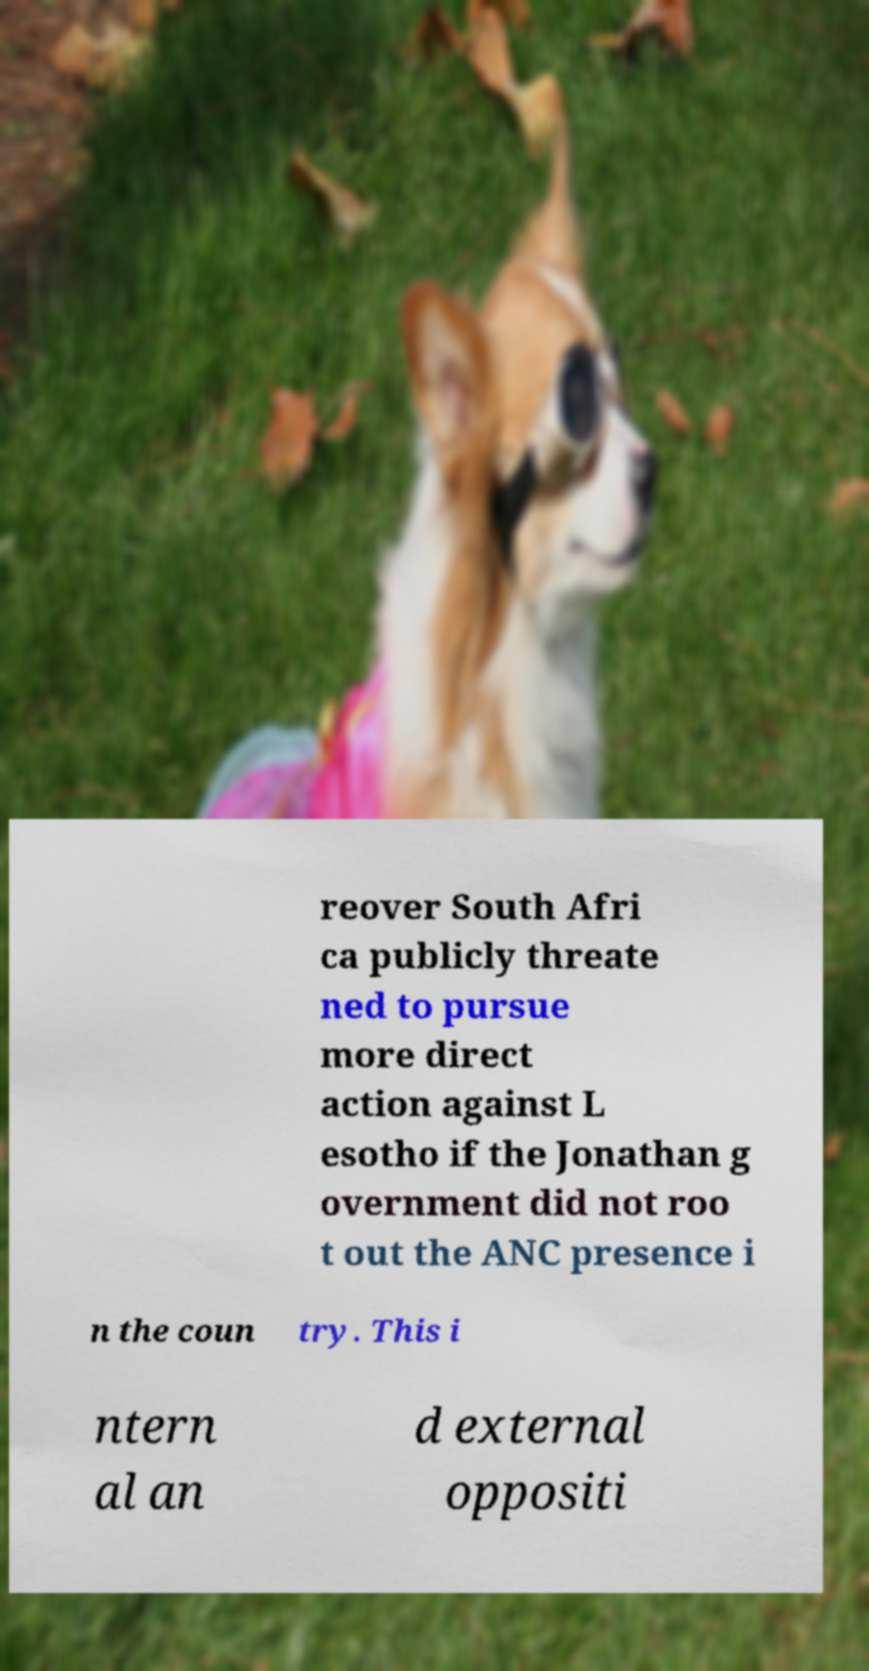Could you assist in decoding the text presented in this image and type it out clearly? reover South Afri ca publicly threate ned to pursue more direct action against L esotho if the Jonathan g overnment did not roo t out the ANC presence i n the coun try. This i ntern al an d external oppositi 